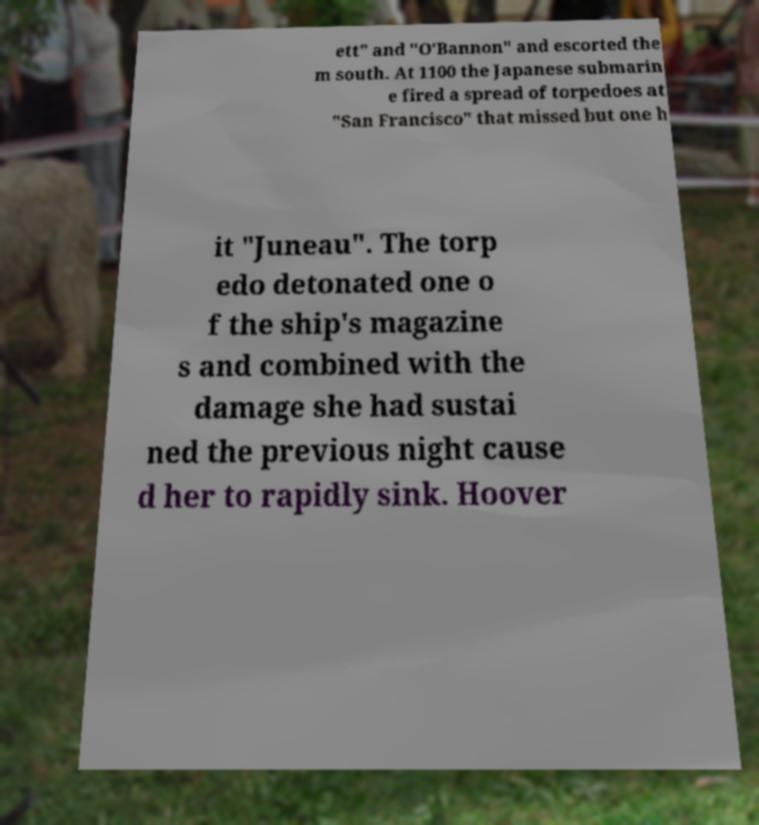Can you accurately transcribe the text from the provided image for me? ett" and "O'Bannon" and escorted the m south. At 1100 the Japanese submarin e fired a spread of torpedoes at "San Francisco" that missed but one h it "Juneau". The torp edo detonated one o f the ship's magazine s and combined with the damage she had sustai ned the previous night cause d her to rapidly sink. Hoover 